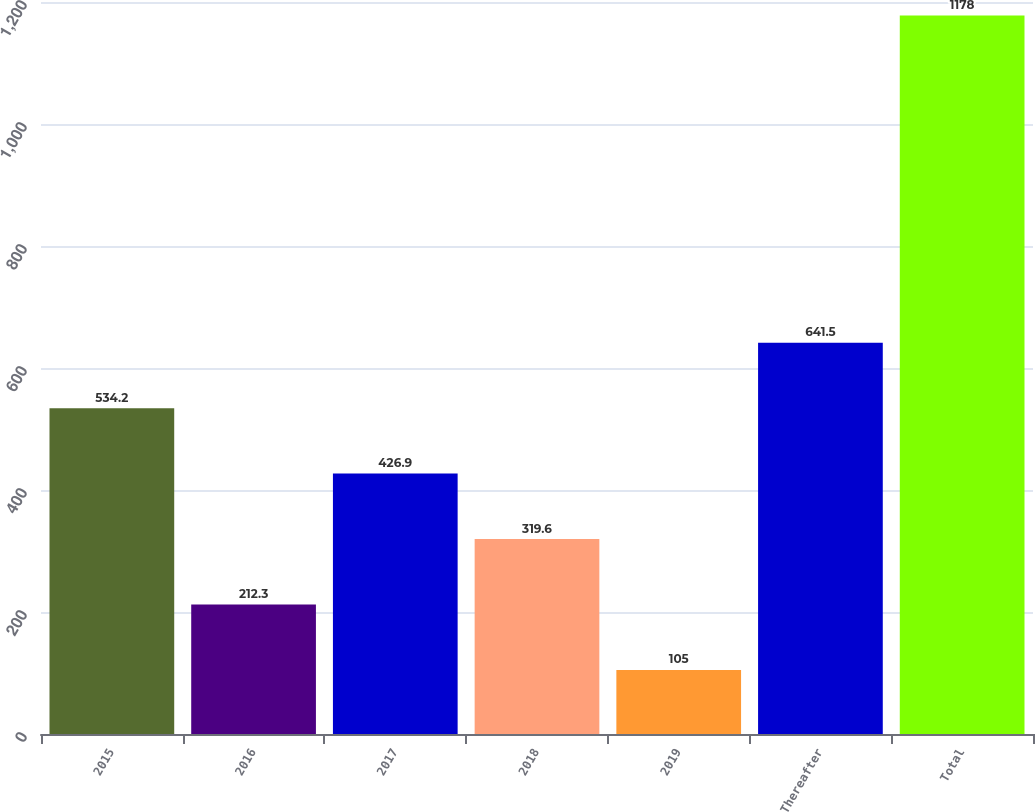<chart> <loc_0><loc_0><loc_500><loc_500><bar_chart><fcel>2015<fcel>2016<fcel>2017<fcel>2018<fcel>2019<fcel>Thereafter<fcel>Total<nl><fcel>534.2<fcel>212.3<fcel>426.9<fcel>319.6<fcel>105<fcel>641.5<fcel>1178<nl></chart> 